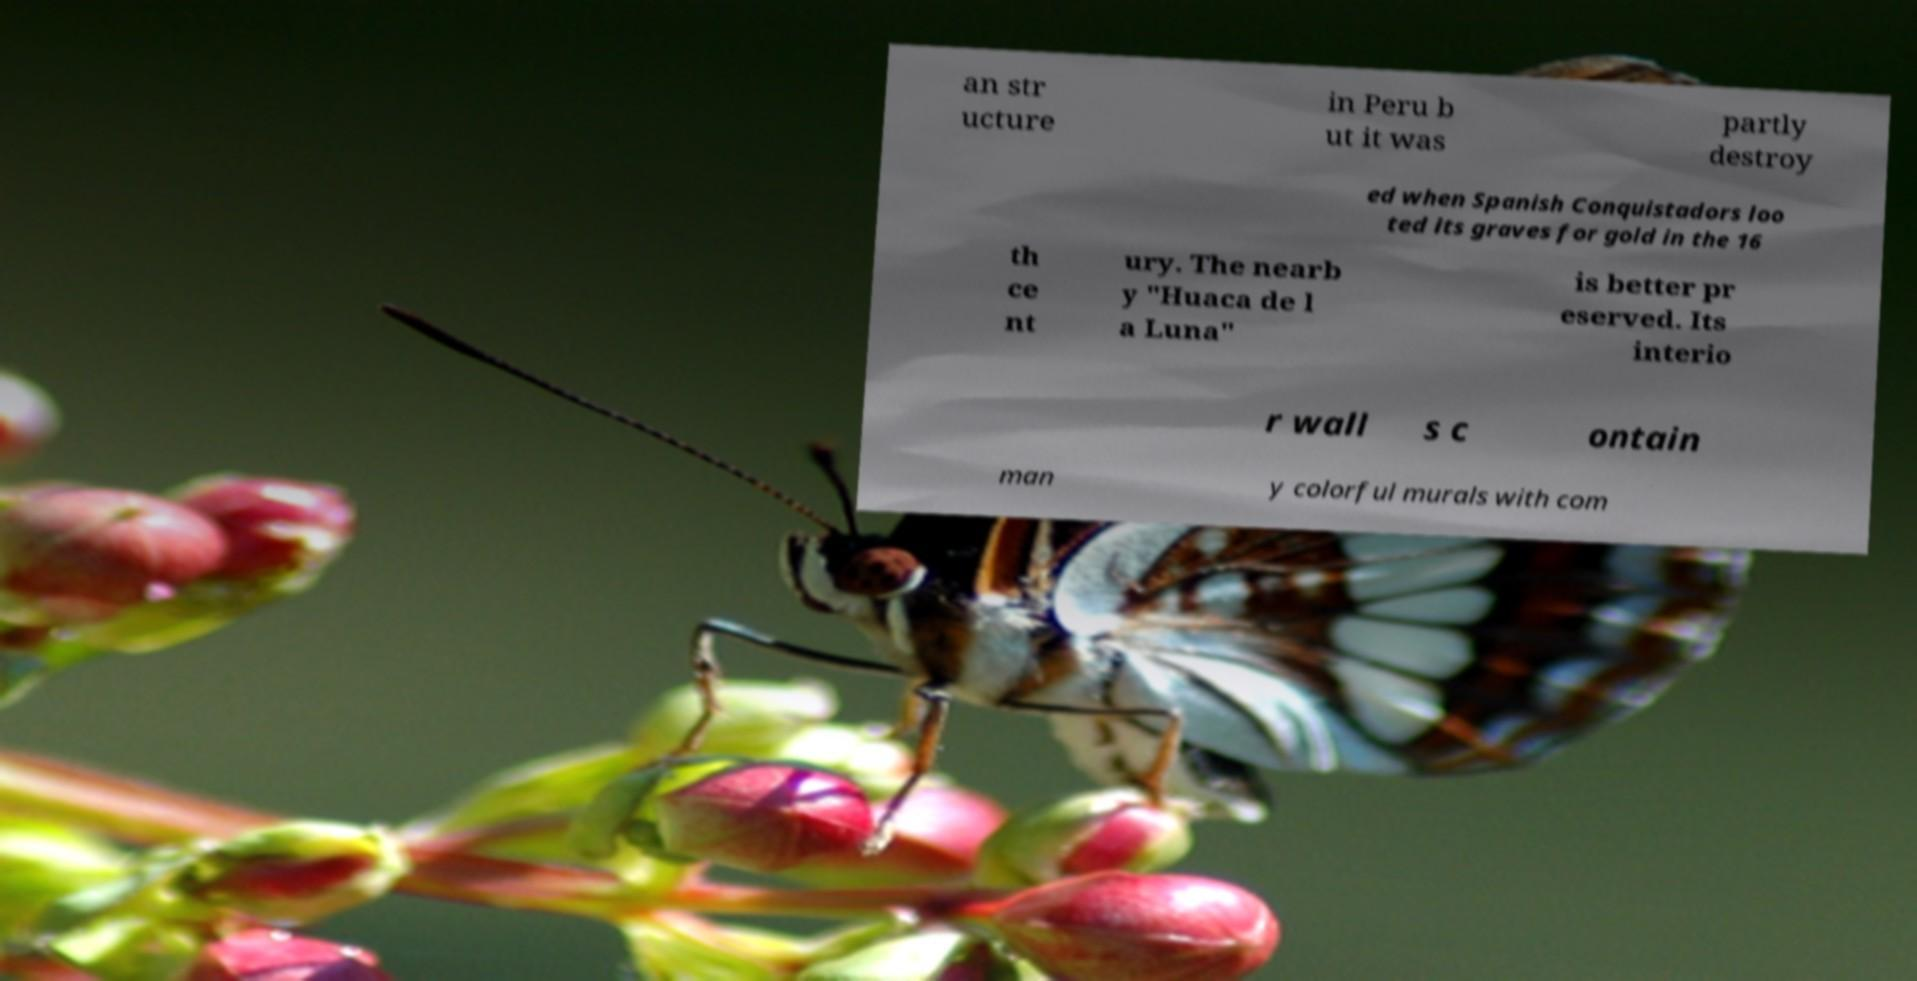Could you extract and type out the text from this image? an str ucture in Peru b ut it was partly destroy ed when Spanish Conquistadors loo ted its graves for gold in the 16 th ce nt ury. The nearb y "Huaca de l a Luna" is better pr eserved. Its interio r wall s c ontain man y colorful murals with com 